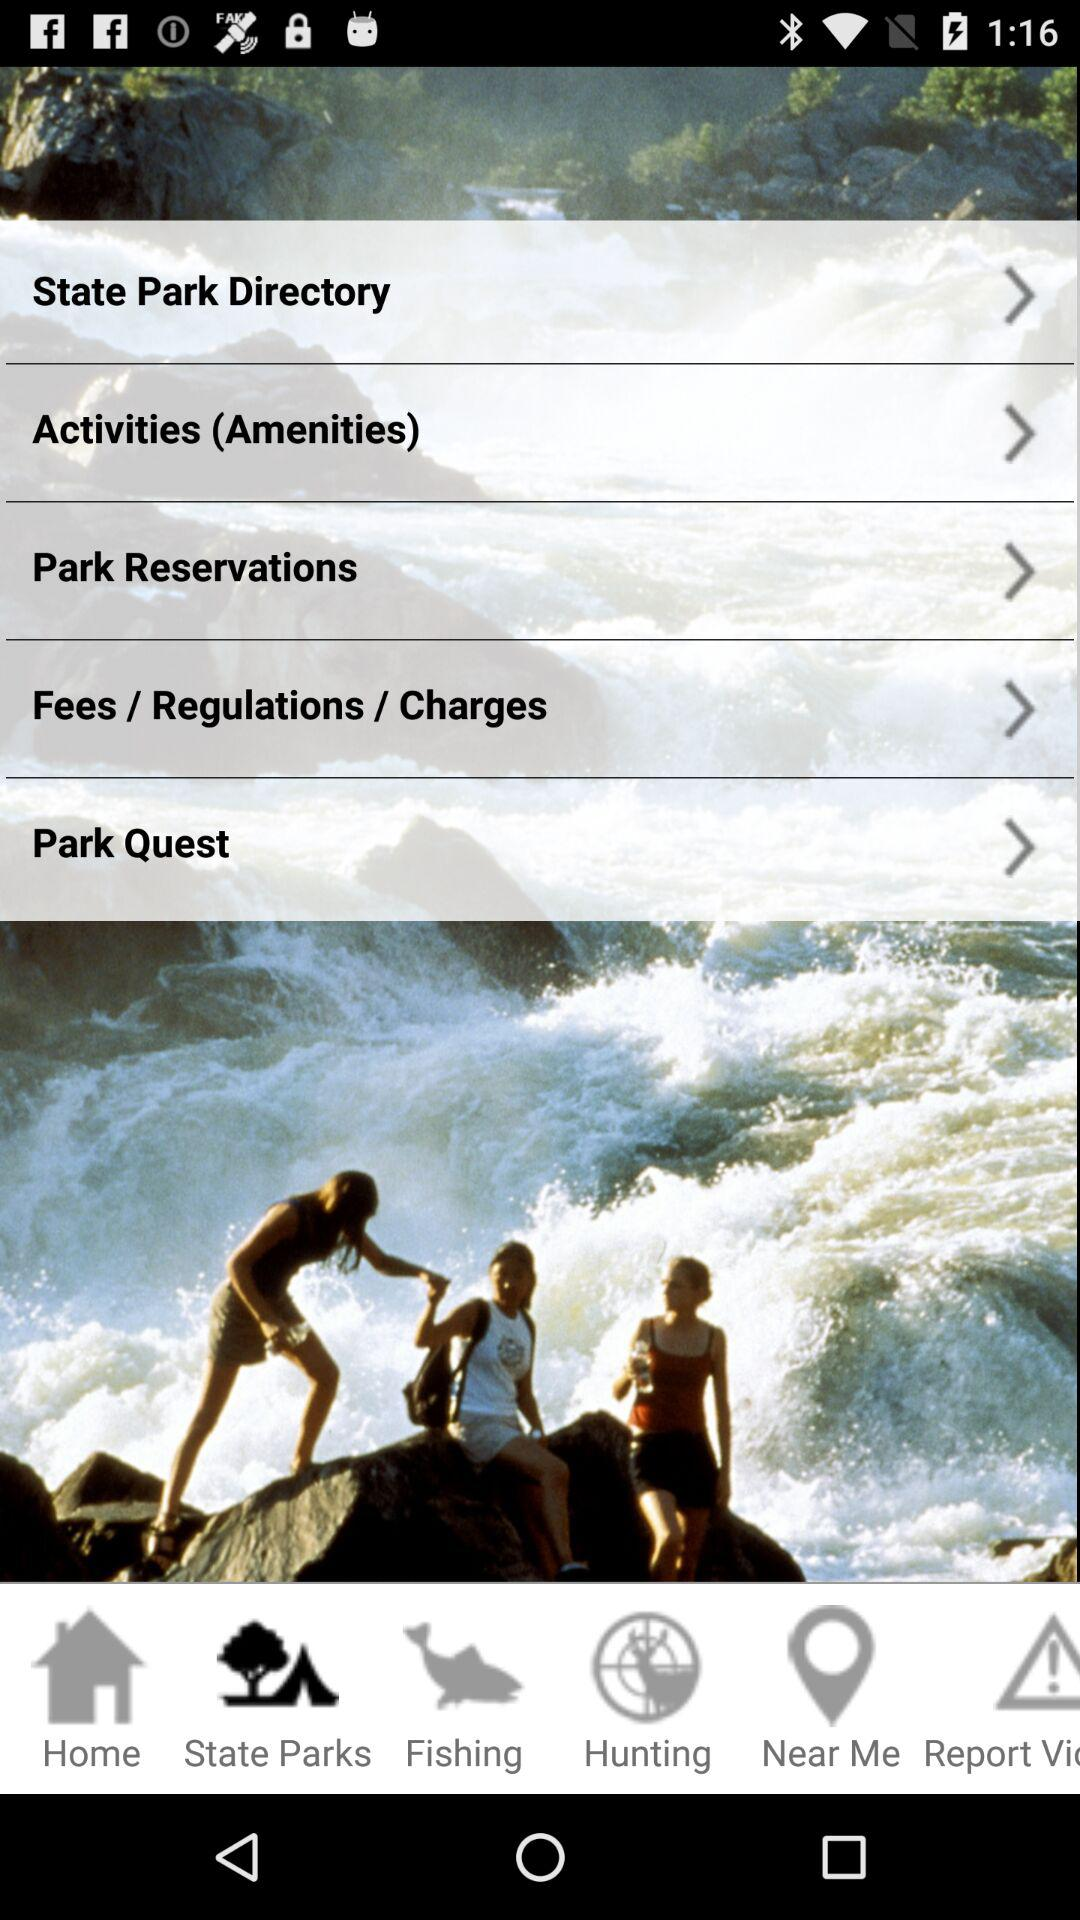Which tab is selected? The selected tab is "State Parks". 